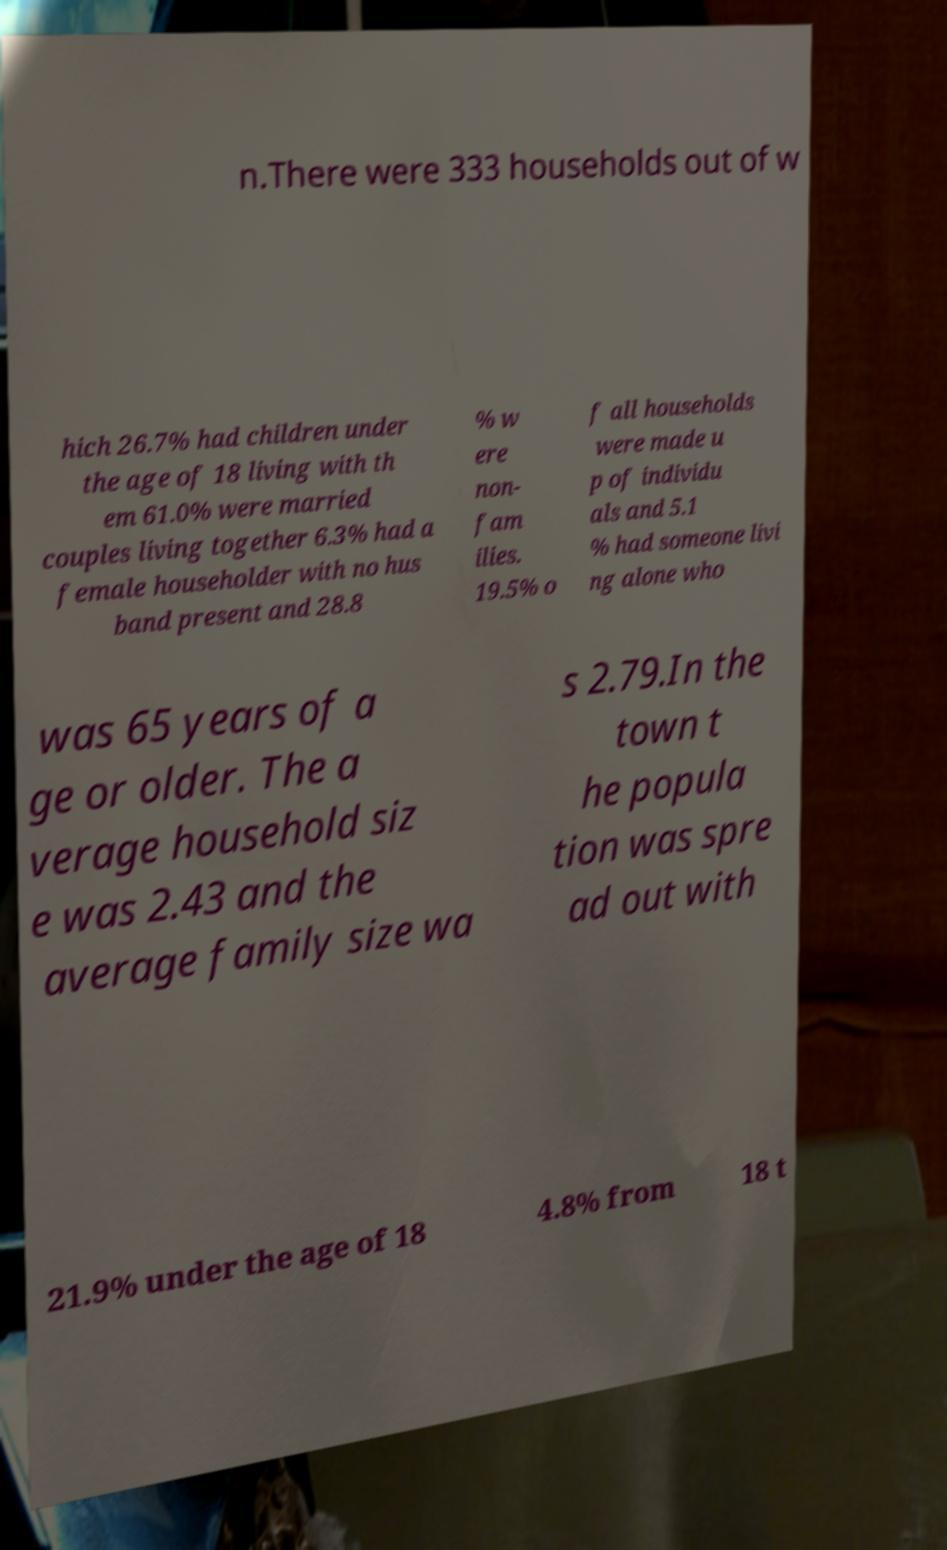What messages or text are displayed in this image? I need them in a readable, typed format. n.There were 333 households out of w hich 26.7% had children under the age of 18 living with th em 61.0% were married couples living together 6.3% had a female householder with no hus band present and 28.8 % w ere non- fam ilies. 19.5% o f all households were made u p of individu als and 5.1 % had someone livi ng alone who was 65 years of a ge or older. The a verage household siz e was 2.43 and the average family size wa s 2.79.In the town t he popula tion was spre ad out with 21.9% under the age of 18 4.8% from 18 t 